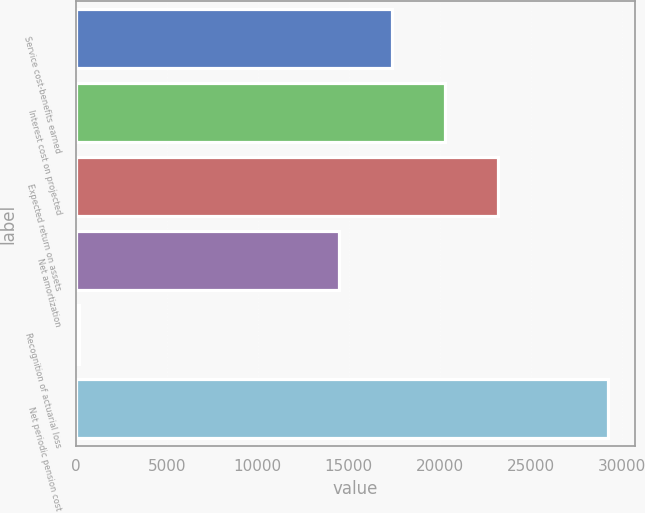Convert chart to OTSL. <chart><loc_0><loc_0><loc_500><loc_500><bar_chart><fcel>Service cost-benefits earned<fcel>Interest cost on projected<fcel>Expected return on assets<fcel>Net amortization<fcel>Recognition of actuarial loss<fcel>Net periodic pension cost<nl><fcel>17370<fcel>20275<fcel>23180<fcel>14465<fcel>180<fcel>29230<nl></chart> 